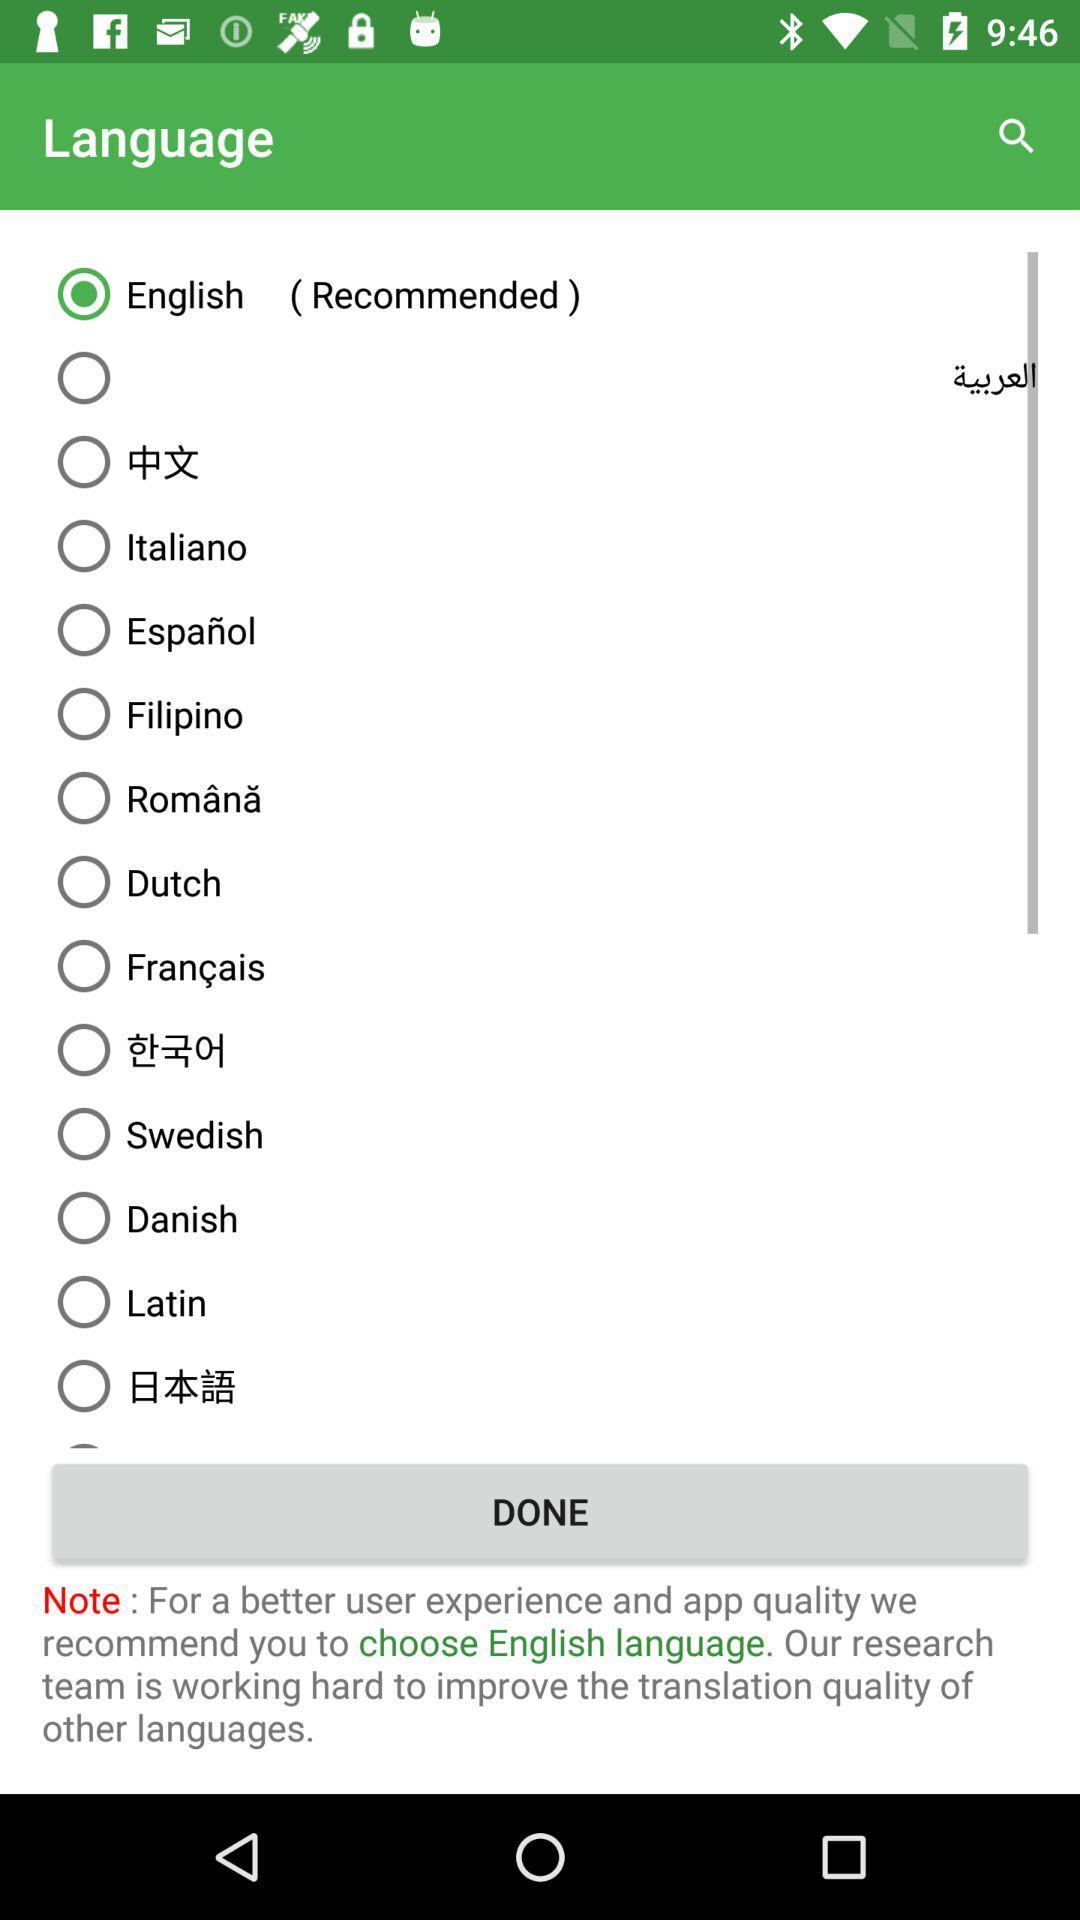Which language is selected? The selected language is English. 